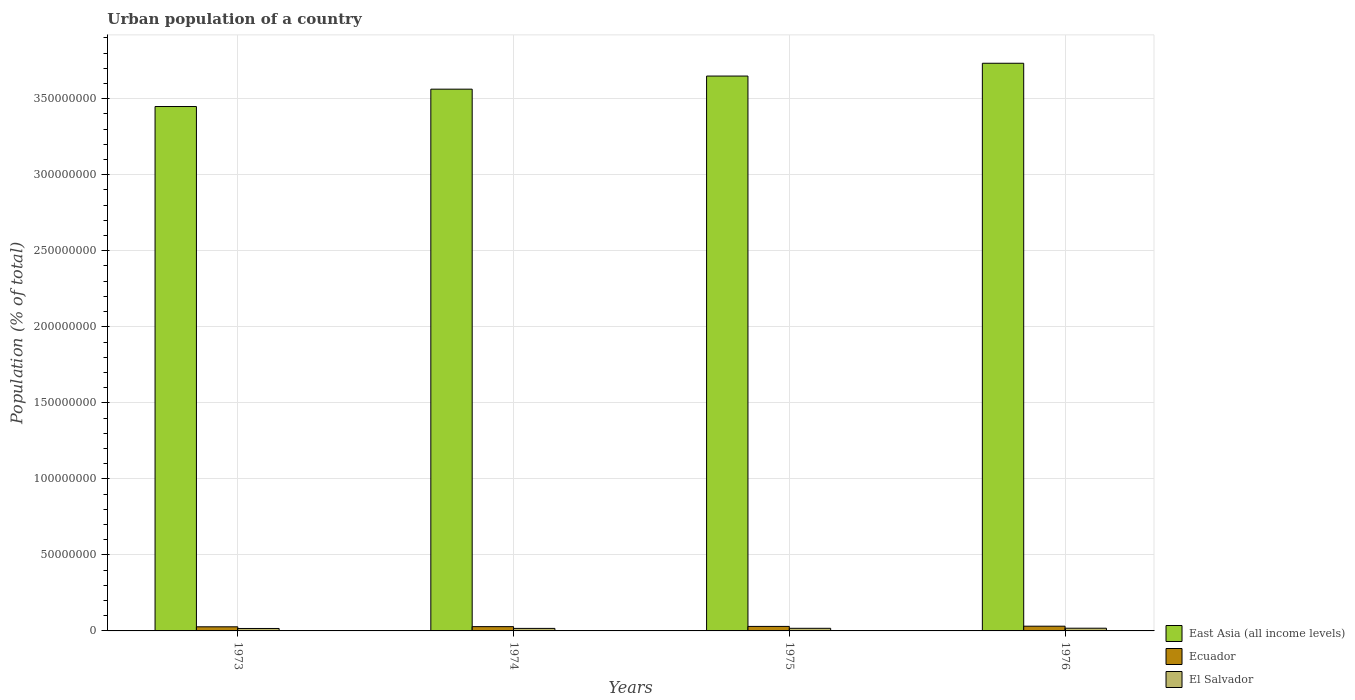How many different coloured bars are there?
Your response must be concise. 3. Are the number of bars per tick equal to the number of legend labels?
Make the answer very short. Yes. Are the number of bars on each tick of the X-axis equal?
Make the answer very short. Yes. What is the label of the 3rd group of bars from the left?
Offer a terse response. 1975. What is the urban population in East Asia (all income levels) in 1975?
Your answer should be compact. 3.65e+08. Across all years, what is the maximum urban population in East Asia (all income levels)?
Give a very brief answer. 3.73e+08. Across all years, what is the minimum urban population in El Salvador?
Offer a terse response. 1.60e+06. In which year was the urban population in El Salvador maximum?
Make the answer very short. 1976. In which year was the urban population in El Salvador minimum?
Your answer should be very brief. 1973. What is the total urban population in El Salvador in the graph?
Your answer should be compact. 6.77e+06. What is the difference between the urban population in Ecuador in 1974 and that in 1976?
Offer a very short reply. -2.89e+05. What is the difference between the urban population in El Salvador in 1973 and the urban population in East Asia (all income levels) in 1975?
Keep it short and to the point. -3.63e+08. What is the average urban population in East Asia (all income levels) per year?
Offer a terse response. 3.60e+08. In the year 1975, what is the difference between the urban population in East Asia (all income levels) and urban population in El Salvador?
Make the answer very short. 3.63e+08. What is the ratio of the urban population in Ecuador in 1973 to that in 1975?
Your response must be concise. 0.91. Is the urban population in East Asia (all income levels) in 1974 less than that in 1975?
Keep it short and to the point. Yes. Is the difference between the urban population in East Asia (all income levels) in 1973 and 1976 greater than the difference between the urban population in El Salvador in 1973 and 1976?
Offer a very short reply. No. What is the difference between the highest and the second highest urban population in Ecuador?
Offer a terse response. 1.47e+05. What is the difference between the highest and the lowest urban population in El Salvador?
Your answer should be very brief. 1.78e+05. In how many years, is the urban population in El Salvador greater than the average urban population in El Salvador taken over all years?
Offer a terse response. 2. Is the sum of the urban population in Ecuador in 1973 and 1976 greater than the maximum urban population in El Salvador across all years?
Give a very brief answer. Yes. What does the 1st bar from the left in 1974 represents?
Make the answer very short. East Asia (all income levels). What does the 3rd bar from the right in 1973 represents?
Keep it short and to the point. East Asia (all income levels). How many bars are there?
Provide a succinct answer. 12. Are all the bars in the graph horizontal?
Your answer should be very brief. No. How many years are there in the graph?
Provide a short and direct response. 4. What is the difference between two consecutive major ticks on the Y-axis?
Your answer should be very brief. 5.00e+07. Are the values on the major ticks of Y-axis written in scientific E-notation?
Give a very brief answer. No. What is the title of the graph?
Make the answer very short. Urban population of a country. Does "Europe(all income levels)" appear as one of the legend labels in the graph?
Make the answer very short. No. What is the label or title of the Y-axis?
Provide a short and direct response. Population (% of total). What is the Population (% of total) in East Asia (all income levels) in 1973?
Ensure brevity in your answer.  3.45e+08. What is the Population (% of total) of Ecuador in 1973?
Your answer should be compact. 2.70e+06. What is the Population (% of total) of El Salvador in 1973?
Your answer should be compact. 1.60e+06. What is the Population (% of total) in East Asia (all income levels) in 1974?
Your response must be concise. 3.56e+08. What is the Population (% of total) of Ecuador in 1974?
Your answer should be compact. 2.82e+06. What is the Population (% of total) in El Salvador in 1974?
Provide a short and direct response. 1.66e+06. What is the Population (% of total) in East Asia (all income levels) in 1975?
Make the answer very short. 3.65e+08. What is the Population (% of total) in Ecuador in 1975?
Give a very brief answer. 2.96e+06. What is the Population (% of total) in El Salvador in 1975?
Your answer should be very brief. 1.72e+06. What is the Population (% of total) of East Asia (all income levels) in 1976?
Keep it short and to the point. 3.73e+08. What is the Population (% of total) in Ecuador in 1976?
Provide a succinct answer. 3.11e+06. What is the Population (% of total) in El Salvador in 1976?
Make the answer very short. 1.78e+06. Across all years, what is the maximum Population (% of total) of East Asia (all income levels)?
Your response must be concise. 3.73e+08. Across all years, what is the maximum Population (% of total) of Ecuador?
Give a very brief answer. 3.11e+06. Across all years, what is the maximum Population (% of total) of El Salvador?
Your response must be concise. 1.78e+06. Across all years, what is the minimum Population (% of total) in East Asia (all income levels)?
Your response must be concise. 3.45e+08. Across all years, what is the minimum Population (% of total) in Ecuador?
Offer a very short reply. 2.70e+06. Across all years, what is the minimum Population (% of total) of El Salvador?
Provide a short and direct response. 1.60e+06. What is the total Population (% of total) in East Asia (all income levels) in the graph?
Provide a short and direct response. 1.44e+09. What is the total Population (% of total) in Ecuador in the graph?
Keep it short and to the point. 1.16e+07. What is the total Population (% of total) of El Salvador in the graph?
Your answer should be compact. 6.77e+06. What is the difference between the Population (% of total) of East Asia (all income levels) in 1973 and that in 1974?
Your answer should be compact. -1.14e+07. What is the difference between the Population (% of total) in Ecuador in 1973 and that in 1974?
Provide a short and direct response. -1.15e+05. What is the difference between the Population (% of total) in El Salvador in 1973 and that in 1974?
Your response must be concise. -5.90e+04. What is the difference between the Population (% of total) in East Asia (all income levels) in 1973 and that in 1975?
Provide a succinct answer. -2.00e+07. What is the difference between the Population (% of total) of Ecuador in 1973 and that in 1975?
Your answer should be very brief. -2.56e+05. What is the difference between the Population (% of total) in El Salvador in 1973 and that in 1975?
Your answer should be very brief. -1.18e+05. What is the difference between the Population (% of total) in East Asia (all income levels) in 1973 and that in 1976?
Provide a short and direct response. -2.85e+07. What is the difference between the Population (% of total) in Ecuador in 1973 and that in 1976?
Provide a short and direct response. -4.03e+05. What is the difference between the Population (% of total) in El Salvador in 1973 and that in 1976?
Your answer should be compact. -1.78e+05. What is the difference between the Population (% of total) in East Asia (all income levels) in 1974 and that in 1975?
Your answer should be very brief. -8.62e+06. What is the difference between the Population (% of total) in Ecuador in 1974 and that in 1975?
Provide a short and direct response. -1.42e+05. What is the difference between the Population (% of total) in El Salvador in 1974 and that in 1975?
Your response must be concise. -5.93e+04. What is the difference between the Population (% of total) of East Asia (all income levels) in 1974 and that in 1976?
Your answer should be very brief. -1.70e+07. What is the difference between the Population (% of total) in Ecuador in 1974 and that in 1976?
Keep it short and to the point. -2.89e+05. What is the difference between the Population (% of total) in El Salvador in 1974 and that in 1976?
Offer a terse response. -1.19e+05. What is the difference between the Population (% of total) of East Asia (all income levels) in 1975 and that in 1976?
Give a very brief answer. -8.42e+06. What is the difference between the Population (% of total) in Ecuador in 1975 and that in 1976?
Provide a short and direct response. -1.47e+05. What is the difference between the Population (% of total) in El Salvador in 1975 and that in 1976?
Offer a terse response. -5.95e+04. What is the difference between the Population (% of total) of East Asia (all income levels) in 1973 and the Population (% of total) of Ecuador in 1974?
Offer a very short reply. 3.42e+08. What is the difference between the Population (% of total) in East Asia (all income levels) in 1973 and the Population (% of total) in El Salvador in 1974?
Ensure brevity in your answer.  3.43e+08. What is the difference between the Population (% of total) of Ecuador in 1973 and the Population (% of total) of El Salvador in 1974?
Offer a very short reply. 1.04e+06. What is the difference between the Population (% of total) of East Asia (all income levels) in 1973 and the Population (% of total) of Ecuador in 1975?
Provide a short and direct response. 3.42e+08. What is the difference between the Population (% of total) of East Asia (all income levels) in 1973 and the Population (% of total) of El Salvador in 1975?
Make the answer very short. 3.43e+08. What is the difference between the Population (% of total) of Ecuador in 1973 and the Population (% of total) of El Salvador in 1975?
Your answer should be very brief. 9.82e+05. What is the difference between the Population (% of total) in East Asia (all income levels) in 1973 and the Population (% of total) in Ecuador in 1976?
Offer a very short reply. 3.42e+08. What is the difference between the Population (% of total) in East Asia (all income levels) in 1973 and the Population (% of total) in El Salvador in 1976?
Provide a short and direct response. 3.43e+08. What is the difference between the Population (% of total) in Ecuador in 1973 and the Population (% of total) in El Salvador in 1976?
Keep it short and to the point. 9.23e+05. What is the difference between the Population (% of total) in East Asia (all income levels) in 1974 and the Population (% of total) in Ecuador in 1975?
Give a very brief answer. 3.53e+08. What is the difference between the Population (% of total) of East Asia (all income levels) in 1974 and the Population (% of total) of El Salvador in 1975?
Your answer should be compact. 3.55e+08. What is the difference between the Population (% of total) of Ecuador in 1974 and the Population (% of total) of El Salvador in 1975?
Provide a succinct answer. 1.10e+06. What is the difference between the Population (% of total) of East Asia (all income levels) in 1974 and the Population (% of total) of Ecuador in 1976?
Keep it short and to the point. 3.53e+08. What is the difference between the Population (% of total) in East Asia (all income levels) in 1974 and the Population (% of total) in El Salvador in 1976?
Provide a succinct answer. 3.54e+08. What is the difference between the Population (% of total) of Ecuador in 1974 and the Population (% of total) of El Salvador in 1976?
Provide a succinct answer. 1.04e+06. What is the difference between the Population (% of total) in East Asia (all income levels) in 1975 and the Population (% of total) in Ecuador in 1976?
Provide a succinct answer. 3.62e+08. What is the difference between the Population (% of total) in East Asia (all income levels) in 1975 and the Population (% of total) in El Salvador in 1976?
Ensure brevity in your answer.  3.63e+08. What is the difference between the Population (% of total) in Ecuador in 1975 and the Population (% of total) in El Salvador in 1976?
Make the answer very short. 1.18e+06. What is the average Population (% of total) of East Asia (all income levels) per year?
Your answer should be compact. 3.60e+08. What is the average Population (% of total) of Ecuador per year?
Your response must be concise. 2.90e+06. What is the average Population (% of total) in El Salvador per year?
Your response must be concise. 1.69e+06. In the year 1973, what is the difference between the Population (% of total) in East Asia (all income levels) and Population (% of total) in Ecuador?
Make the answer very short. 3.42e+08. In the year 1973, what is the difference between the Population (% of total) of East Asia (all income levels) and Population (% of total) of El Salvador?
Keep it short and to the point. 3.43e+08. In the year 1973, what is the difference between the Population (% of total) in Ecuador and Population (% of total) in El Salvador?
Keep it short and to the point. 1.10e+06. In the year 1974, what is the difference between the Population (% of total) in East Asia (all income levels) and Population (% of total) in Ecuador?
Give a very brief answer. 3.53e+08. In the year 1974, what is the difference between the Population (% of total) of East Asia (all income levels) and Population (% of total) of El Salvador?
Your answer should be very brief. 3.55e+08. In the year 1974, what is the difference between the Population (% of total) of Ecuador and Population (% of total) of El Salvador?
Your response must be concise. 1.16e+06. In the year 1975, what is the difference between the Population (% of total) in East Asia (all income levels) and Population (% of total) in Ecuador?
Give a very brief answer. 3.62e+08. In the year 1975, what is the difference between the Population (% of total) in East Asia (all income levels) and Population (% of total) in El Salvador?
Provide a succinct answer. 3.63e+08. In the year 1975, what is the difference between the Population (% of total) of Ecuador and Population (% of total) of El Salvador?
Keep it short and to the point. 1.24e+06. In the year 1976, what is the difference between the Population (% of total) in East Asia (all income levels) and Population (% of total) in Ecuador?
Your response must be concise. 3.70e+08. In the year 1976, what is the difference between the Population (% of total) in East Asia (all income levels) and Population (% of total) in El Salvador?
Make the answer very short. 3.72e+08. In the year 1976, what is the difference between the Population (% of total) in Ecuador and Population (% of total) in El Salvador?
Your answer should be compact. 1.33e+06. What is the ratio of the Population (% of total) in Ecuador in 1973 to that in 1974?
Keep it short and to the point. 0.96. What is the ratio of the Population (% of total) of El Salvador in 1973 to that in 1974?
Make the answer very short. 0.96. What is the ratio of the Population (% of total) of East Asia (all income levels) in 1973 to that in 1975?
Your answer should be compact. 0.95. What is the ratio of the Population (% of total) in Ecuador in 1973 to that in 1975?
Your answer should be compact. 0.91. What is the ratio of the Population (% of total) in El Salvador in 1973 to that in 1975?
Offer a very short reply. 0.93. What is the ratio of the Population (% of total) of East Asia (all income levels) in 1973 to that in 1976?
Your answer should be compact. 0.92. What is the ratio of the Population (% of total) of Ecuador in 1973 to that in 1976?
Your answer should be compact. 0.87. What is the ratio of the Population (% of total) in El Salvador in 1973 to that in 1976?
Ensure brevity in your answer.  0.9. What is the ratio of the Population (% of total) of East Asia (all income levels) in 1974 to that in 1975?
Ensure brevity in your answer.  0.98. What is the ratio of the Population (% of total) in Ecuador in 1974 to that in 1975?
Provide a short and direct response. 0.95. What is the ratio of the Population (% of total) of El Salvador in 1974 to that in 1975?
Make the answer very short. 0.97. What is the ratio of the Population (% of total) of East Asia (all income levels) in 1974 to that in 1976?
Provide a short and direct response. 0.95. What is the ratio of the Population (% of total) in Ecuador in 1974 to that in 1976?
Your answer should be compact. 0.91. What is the ratio of the Population (% of total) in El Salvador in 1974 to that in 1976?
Your response must be concise. 0.93. What is the ratio of the Population (% of total) of East Asia (all income levels) in 1975 to that in 1976?
Give a very brief answer. 0.98. What is the ratio of the Population (% of total) of Ecuador in 1975 to that in 1976?
Ensure brevity in your answer.  0.95. What is the ratio of the Population (% of total) of El Salvador in 1975 to that in 1976?
Keep it short and to the point. 0.97. What is the difference between the highest and the second highest Population (% of total) in East Asia (all income levels)?
Ensure brevity in your answer.  8.42e+06. What is the difference between the highest and the second highest Population (% of total) of Ecuador?
Offer a very short reply. 1.47e+05. What is the difference between the highest and the second highest Population (% of total) of El Salvador?
Give a very brief answer. 5.95e+04. What is the difference between the highest and the lowest Population (% of total) of East Asia (all income levels)?
Your response must be concise. 2.85e+07. What is the difference between the highest and the lowest Population (% of total) of Ecuador?
Provide a succinct answer. 4.03e+05. What is the difference between the highest and the lowest Population (% of total) of El Salvador?
Keep it short and to the point. 1.78e+05. 